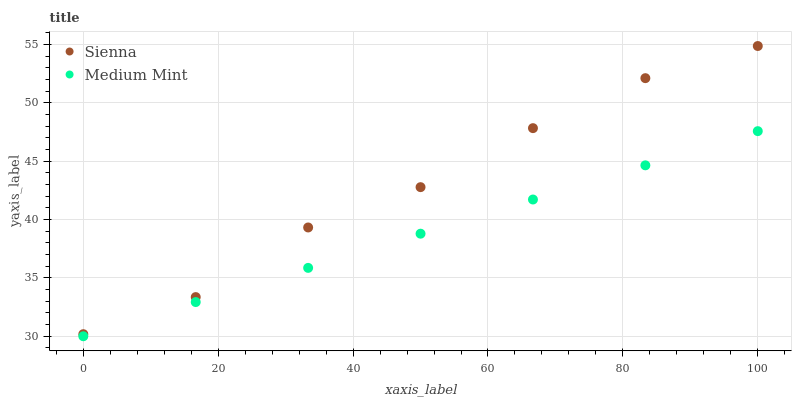Does Medium Mint have the minimum area under the curve?
Answer yes or no. Yes. Does Sienna have the maximum area under the curve?
Answer yes or no. Yes. Does Medium Mint have the maximum area under the curve?
Answer yes or no. No. Is Medium Mint the smoothest?
Answer yes or no. Yes. Is Sienna the roughest?
Answer yes or no. Yes. Is Medium Mint the roughest?
Answer yes or no. No. Does Medium Mint have the lowest value?
Answer yes or no. Yes. Does Sienna have the highest value?
Answer yes or no. Yes. Does Medium Mint have the highest value?
Answer yes or no. No. Is Medium Mint less than Sienna?
Answer yes or no. Yes. Is Sienna greater than Medium Mint?
Answer yes or no. Yes. Does Medium Mint intersect Sienna?
Answer yes or no. No. 